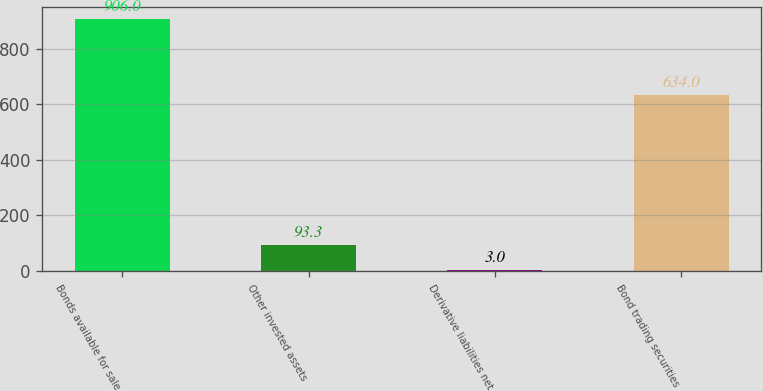Convert chart to OTSL. <chart><loc_0><loc_0><loc_500><loc_500><bar_chart><fcel>Bonds available for sale<fcel>Other invested assets<fcel>Derivative liabilities net<fcel>Bond trading securities<nl><fcel>906<fcel>93.3<fcel>3<fcel>634<nl></chart> 